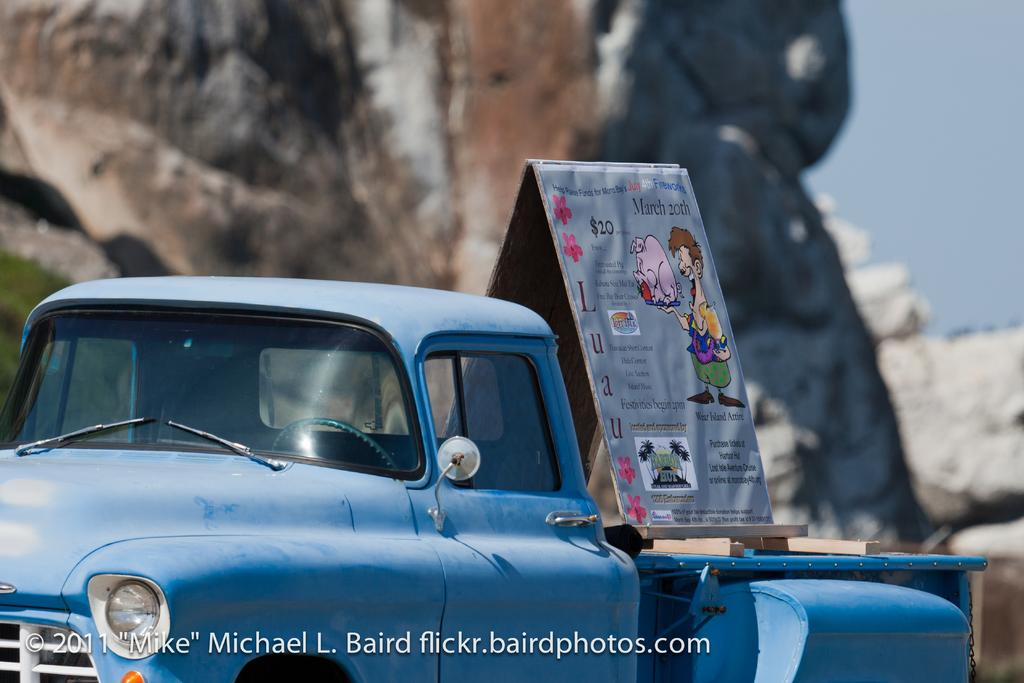What is the main subject of the image? There is a vehicle in the image. What feature does the vehicle have? The vehicle has a board. What is on the board? The board contains images and text. What can be seen in the background of the image? There are rocks in the background of the image. What part of the sky is visible in the image? The sky is visible at the top right of the image. What type of ornament is hanging from the vehicle's rearview mirror in the image? There is no ornament hanging from the vehicle's rearview mirror in the image. Can you see a crown on the board in the image? There is no crown present on the board in the image. 